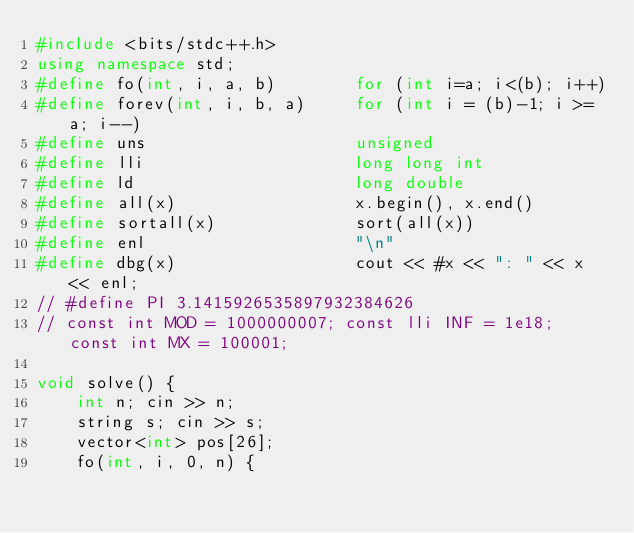<code> <loc_0><loc_0><loc_500><loc_500><_C++_>#include <bits/stdc++.h>
using namespace std;
#define fo(int, i, a, b)        for (int i=a; i<(b); i++)
#define forev(int, i, b, a)     for (int i = (b)-1; i >= a; i--)
#define uns                     unsigned
#define lli                     long long int
#define ld                      long double
#define all(x)                  x.begin(), x.end()
#define sortall(x)              sort(all(x))
#define enl                     "\n"
#define dbg(x)                  cout << #x << ": " << x << enl;
// #define PI 3.1415926535897932384626
// const int MOD = 1000000007; const lli INF = 1e18; const int MX = 100001;

void solve() {
    int n; cin >> n;
    string s; cin >> s;
    vector<int> pos[26];
    fo(int, i, 0, n) {</code> 